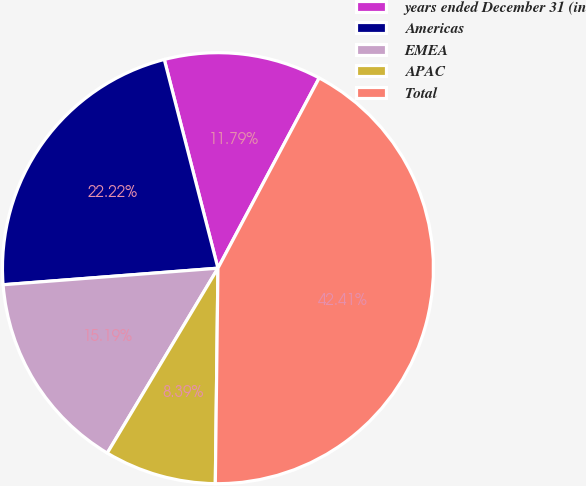Convert chart to OTSL. <chart><loc_0><loc_0><loc_500><loc_500><pie_chart><fcel>years ended December 31 (in<fcel>Americas<fcel>EMEA<fcel>APAC<fcel>Total<nl><fcel>11.79%<fcel>22.22%<fcel>15.19%<fcel>8.39%<fcel>42.41%<nl></chart> 